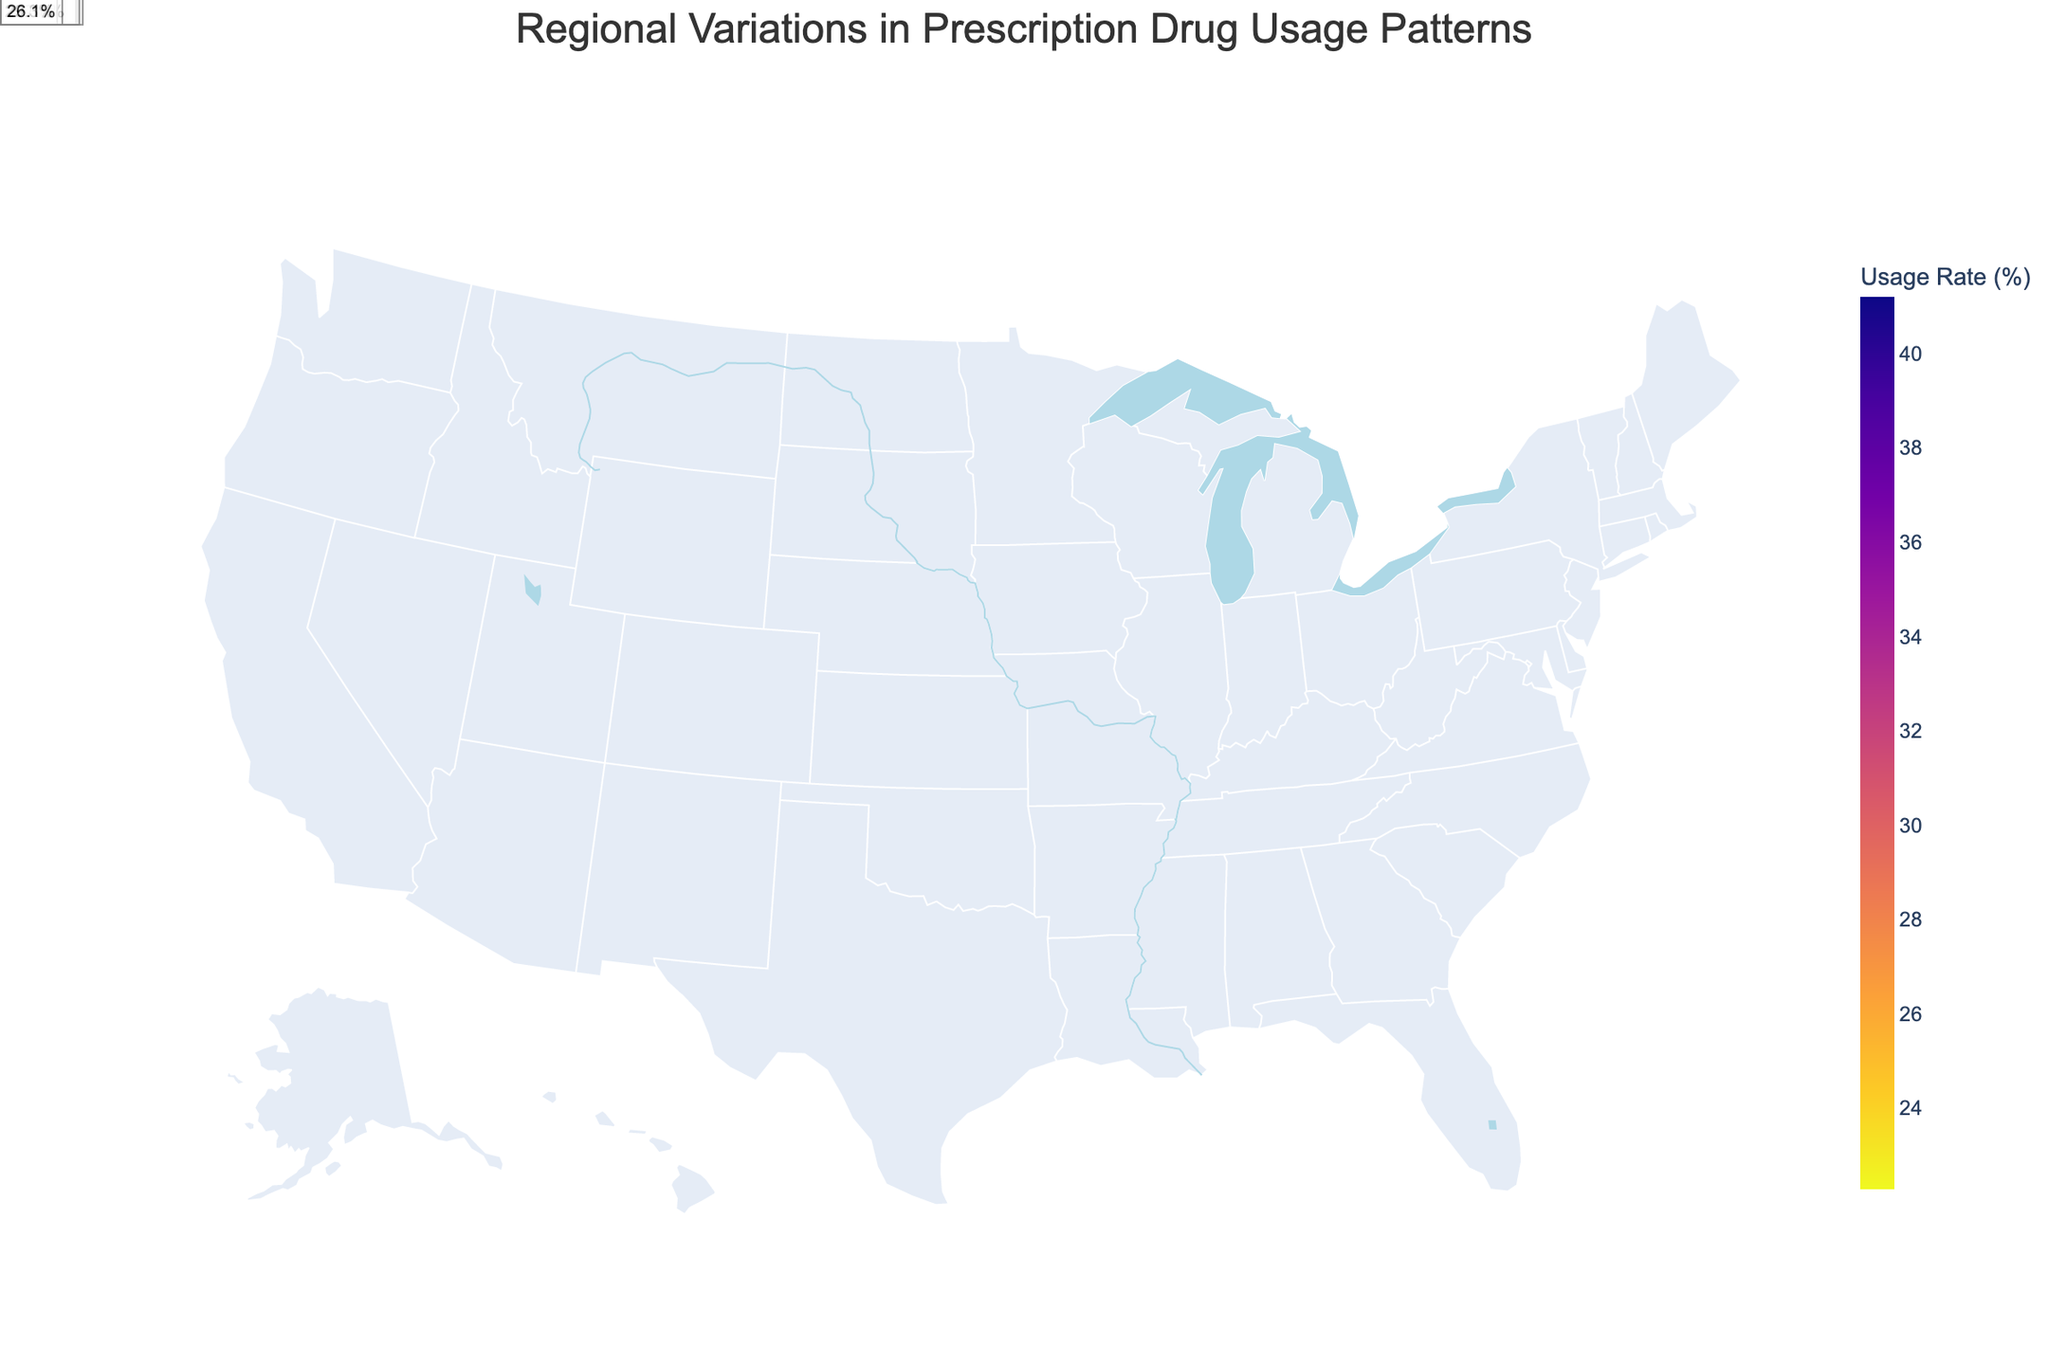What is the title of the figure? The title is usually displayed at the top of the figure. Here, it says "Regional Variations in Prescription Drug Usage Patterns"
Answer: Regional Variations in Prescription Drug Usage Patterns Which region has the highest drug usage rate and what is the value? Scan the map for the region with the highest shaded color, then check the hover data or annotations for the exact value. In this case, Southeast has the highest usage rate with 41.2%
Answer: Southeast, 41.2% What drug is most commonly used in New England? To determine the most commonly used drug in a region, refer to the annotation or hover data for that region. For New England, it is Lipitor
Answer: Lipitor Compare the drug usage rates in Alaska and Hawaii. Which is higher and by how much? Find the usage rates for both Alaska and Hawaii and subtract the smaller value from the larger one. Alaska has 22.3% and Hawaii has 25.6%, so Hawaii's usage rate is higher by 3.3%
Answer: Hawaii is higher by 3.3% Calculate the average drug usage rate across all regions shown on the map. Sum all the usage rates and divide by the number of regions. The rates are (32.5, 28.7, 41.2, 36.9, 30.1, 33.8, 27.4, 22.3, 25.6, 31.5, 39.7, 34.2, 37.8, 29.3, 26.1). Total sum is 477.1 and there are 15 regions, so 477.1 / 15 ≈ 31.8%
Answer: 31.8% Identify the region with the lowest drug usage rate and name the drug. Look for the region with the lightest shading and refer to its annotation or hover data. Alaska has the lowest usage rate of 22.3%, and the drug is Entresto
Answer: Alaska, Entresto How does the usage rate of Keytruda in Florida compare to that of Brilinta in Illinois? Locate the usage rates for Florida and Illinois. Florida has 39.7% and Illinois has 26.1%. Compare these values, noting that 39.7% is greater than 26.1%
Answer: Florida's rate is higher by 13.6% What is the color scale used in the figure? The color scale information is part of the map's legend. It uses the Plasma_r color scale, ranging from dark to light colors
Answer: Plasma_r How many regions have a drug usage rate above 35%? Count the regions with usage rates higher than 35% by referring to the annotations. The regions are Southeast, Midwest, Florida, Texas, and California, so 5 regions
Answer: 5 